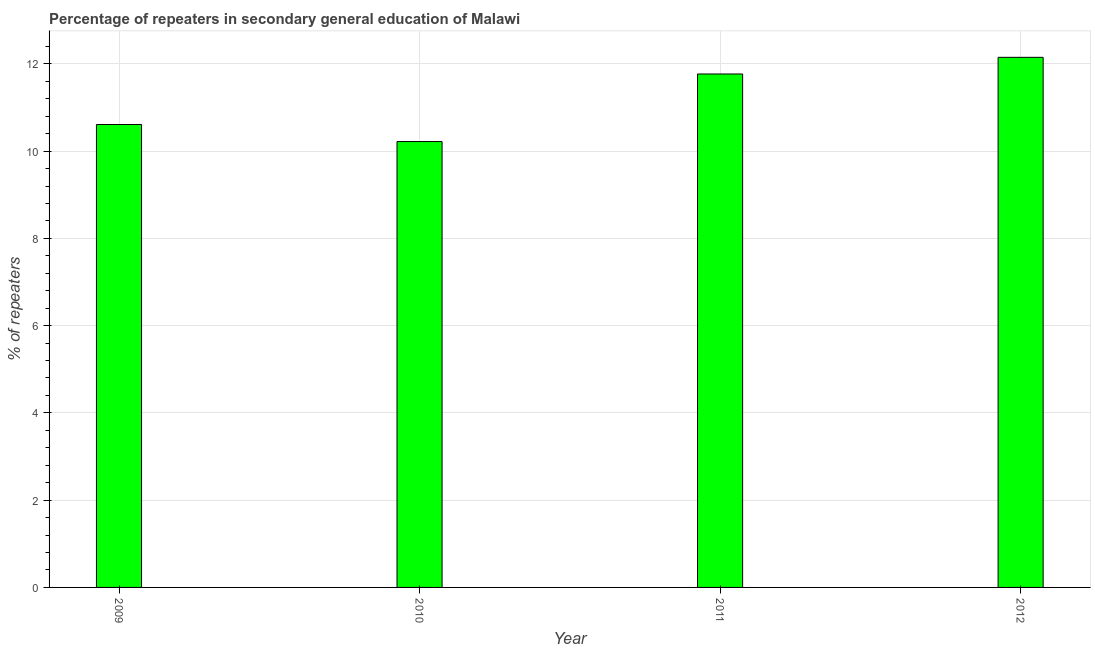Does the graph contain any zero values?
Your answer should be very brief. No. What is the title of the graph?
Keep it short and to the point. Percentage of repeaters in secondary general education of Malawi. What is the label or title of the X-axis?
Keep it short and to the point. Year. What is the label or title of the Y-axis?
Provide a short and direct response. % of repeaters. What is the percentage of repeaters in 2010?
Provide a succinct answer. 10.22. Across all years, what is the maximum percentage of repeaters?
Provide a short and direct response. 12.15. Across all years, what is the minimum percentage of repeaters?
Provide a succinct answer. 10.22. What is the sum of the percentage of repeaters?
Your answer should be compact. 44.74. What is the difference between the percentage of repeaters in 2010 and 2012?
Provide a short and direct response. -1.93. What is the average percentage of repeaters per year?
Give a very brief answer. 11.19. What is the median percentage of repeaters?
Provide a succinct answer. 11.19. In how many years, is the percentage of repeaters greater than 3.2 %?
Offer a very short reply. 4. Do a majority of the years between 2009 and 2012 (inclusive) have percentage of repeaters greater than 2.4 %?
Offer a very short reply. Yes. What is the ratio of the percentage of repeaters in 2009 to that in 2012?
Make the answer very short. 0.87. What is the difference between the highest and the second highest percentage of repeaters?
Keep it short and to the point. 0.38. What is the difference between the highest and the lowest percentage of repeaters?
Give a very brief answer. 1.93. Are all the bars in the graph horizontal?
Offer a very short reply. No. What is the difference between two consecutive major ticks on the Y-axis?
Offer a very short reply. 2. Are the values on the major ticks of Y-axis written in scientific E-notation?
Your response must be concise. No. What is the % of repeaters of 2009?
Provide a succinct answer. 10.61. What is the % of repeaters in 2010?
Give a very brief answer. 10.22. What is the % of repeaters of 2011?
Keep it short and to the point. 11.77. What is the % of repeaters of 2012?
Give a very brief answer. 12.15. What is the difference between the % of repeaters in 2009 and 2010?
Ensure brevity in your answer.  0.39. What is the difference between the % of repeaters in 2009 and 2011?
Provide a short and direct response. -1.16. What is the difference between the % of repeaters in 2009 and 2012?
Provide a succinct answer. -1.54. What is the difference between the % of repeaters in 2010 and 2011?
Ensure brevity in your answer.  -1.55. What is the difference between the % of repeaters in 2010 and 2012?
Give a very brief answer. -1.93. What is the difference between the % of repeaters in 2011 and 2012?
Your answer should be compact. -0.38. What is the ratio of the % of repeaters in 2009 to that in 2010?
Offer a terse response. 1.04. What is the ratio of the % of repeaters in 2009 to that in 2011?
Offer a very short reply. 0.9. What is the ratio of the % of repeaters in 2009 to that in 2012?
Give a very brief answer. 0.87. What is the ratio of the % of repeaters in 2010 to that in 2011?
Keep it short and to the point. 0.87. What is the ratio of the % of repeaters in 2010 to that in 2012?
Give a very brief answer. 0.84. What is the ratio of the % of repeaters in 2011 to that in 2012?
Offer a very short reply. 0.97. 